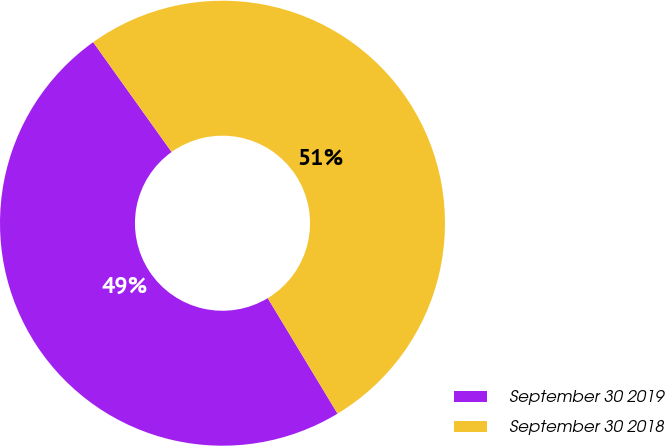Convert chart. <chart><loc_0><loc_0><loc_500><loc_500><pie_chart><fcel>September 30 2019<fcel>September 30 2018<nl><fcel>48.78%<fcel>51.22%<nl></chart> 